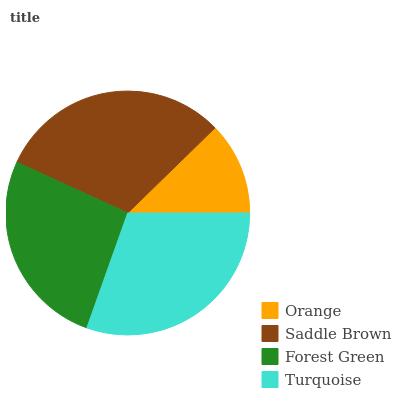Is Orange the minimum?
Answer yes or no. Yes. Is Saddle Brown the maximum?
Answer yes or no. Yes. Is Forest Green the minimum?
Answer yes or no. No. Is Forest Green the maximum?
Answer yes or no. No. Is Saddle Brown greater than Forest Green?
Answer yes or no. Yes. Is Forest Green less than Saddle Brown?
Answer yes or no. Yes. Is Forest Green greater than Saddle Brown?
Answer yes or no. No. Is Saddle Brown less than Forest Green?
Answer yes or no. No. Is Turquoise the high median?
Answer yes or no. Yes. Is Forest Green the low median?
Answer yes or no. Yes. Is Orange the high median?
Answer yes or no. No. Is Saddle Brown the low median?
Answer yes or no. No. 